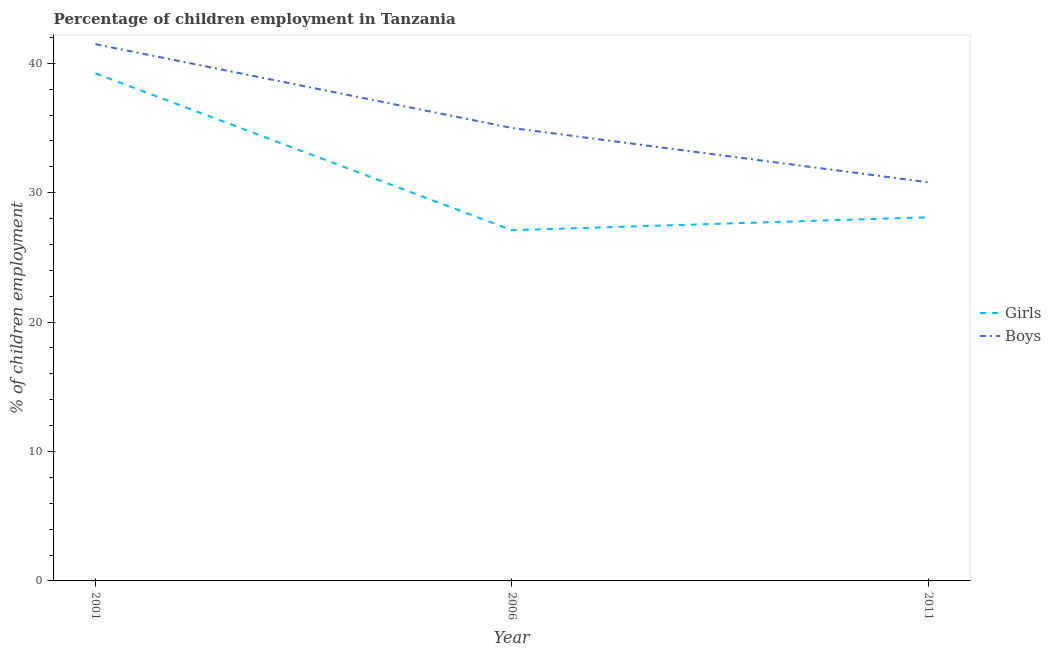Does the line corresponding to percentage of employed boys intersect with the line corresponding to percentage of employed girls?
Provide a succinct answer. No. Is the number of lines equal to the number of legend labels?
Your answer should be compact. Yes. What is the percentage of employed girls in 2011?
Offer a terse response. 28.1. Across all years, what is the maximum percentage of employed girls?
Provide a succinct answer. 39.22. Across all years, what is the minimum percentage of employed boys?
Your answer should be compact. 30.8. In which year was the percentage of employed boys maximum?
Give a very brief answer. 2001. What is the total percentage of employed boys in the graph?
Your answer should be very brief. 107.27. What is the difference between the percentage of employed girls in 2001 and that in 2011?
Offer a terse response. 11.12. What is the difference between the percentage of employed boys in 2006 and the percentage of employed girls in 2001?
Your answer should be compact. -4.22. What is the average percentage of employed girls per year?
Your answer should be compact. 31.47. In the year 2011, what is the difference between the percentage of employed girls and percentage of employed boys?
Keep it short and to the point. -2.7. In how many years, is the percentage of employed boys greater than 28 %?
Provide a short and direct response. 3. What is the ratio of the percentage of employed girls in 2006 to that in 2011?
Your response must be concise. 0.96. Is the percentage of employed boys in 2001 less than that in 2006?
Give a very brief answer. No. Is the difference between the percentage of employed girls in 2001 and 2011 greater than the difference between the percentage of employed boys in 2001 and 2011?
Give a very brief answer. Yes. What is the difference between the highest and the second highest percentage of employed boys?
Give a very brief answer. 6.47. What is the difference between the highest and the lowest percentage of employed girls?
Offer a terse response. 12.12. In how many years, is the percentage of employed boys greater than the average percentage of employed boys taken over all years?
Offer a terse response. 1. Is the sum of the percentage of employed boys in 2006 and 2011 greater than the maximum percentage of employed girls across all years?
Your answer should be very brief. Yes. Does the percentage of employed girls monotonically increase over the years?
Your response must be concise. No. Is the percentage of employed girls strictly greater than the percentage of employed boys over the years?
Your response must be concise. No. Is the percentage of employed girls strictly less than the percentage of employed boys over the years?
Ensure brevity in your answer.  Yes. How many years are there in the graph?
Offer a terse response. 3. What is the difference between two consecutive major ticks on the Y-axis?
Give a very brief answer. 10. How are the legend labels stacked?
Offer a very short reply. Vertical. What is the title of the graph?
Offer a terse response. Percentage of children employment in Tanzania. Does "Males" appear as one of the legend labels in the graph?
Your answer should be very brief. No. What is the label or title of the X-axis?
Your response must be concise. Year. What is the label or title of the Y-axis?
Your answer should be compact. % of children employment. What is the % of children employment of Girls in 2001?
Your answer should be very brief. 39.22. What is the % of children employment of Boys in 2001?
Give a very brief answer. 41.47. What is the % of children employment in Girls in 2006?
Offer a very short reply. 27.1. What is the % of children employment of Girls in 2011?
Give a very brief answer. 28.1. What is the % of children employment of Boys in 2011?
Keep it short and to the point. 30.8. Across all years, what is the maximum % of children employment in Girls?
Keep it short and to the point. 39.22. Across all years, what is the maximum % of children employment in Boys?
Give a very brief answer. 41.47. Across all years, what is the minimum % of children employment of Girls?
Provide a short and direct response. 27.1. Across all years, what is the minimum % of children employment in Boys?
Your response must be concise. 30.8. What is the total % of children employment in Girls in the graph?
Make the answer very short. 94.42. What is the total % of children employment of Boys in the graph?
Offer a very short reply. 107.27. What is the difference between the % of children employment in Girls in 2001 and that in 2006?
Provide a succinct answer. 12.12. What is the difference between the % of children employment of Boys in 2001 and that in 2006?
Provide a succinct answer. 6.47. What is the difference between the % of children employment of Girls in 2001 and that in 2011?
Give a very brief answer. 11.12. What is the difference between the % of children employment of Boys in 2001 and that in 2011?
Keep it short and to the point. 10.67. What is the difference between the % of children employment of Girls in 2006 and that in 2011?
Make the answer very short. -1. What is the difference between the % of children employment of Girls in 2001 and the % of children employment of Boys in 2006?
Make the answer very short. 4.22. What is the difference between the % of children employment in Girls in 2001 and the % of children employment in Boys in 2011?
Ensure brevity in your answer.  8.42. What is the difference between the % of children employment in Girls in 2006 and the % of children employment in Boys in 2011?
Provide a succinct answer. -3.7. What is the average % of children employment in Girls per year?
Provide a succinct answer. 31.47. What is the average % of children employment in Boys per year?
Provide a short and direct response. 35.76. In the year 2001, what is the difference between the % of children employment of Girls and % of children employment of Boys?
Your response must be concise. -2.25. What is the ratio of the % of children employment of Girls in 2001 to that in 2006?
Your answer should be very brief. 1.45. What is the ratio of the % of children employment in Boys in 2001 to that in 2006?
Your answer should be compact. 1.19. What is the ratio of the % of children employment in Girls in 2001 to that in 2011?
Your response must be concise. 1.4. What is the ratio of the % of children employment of Boys in 2001 to that in 2011?
Give a very brief answer. 1.35. What is the ratio of the % of children employment in Girls in 2006 to that in 2011?
Make the answer very short. 0.96. What is the ratio of the % of children employment of Boys in 2006 to that in 2011?
Your answer should be very brief. 1.14. What is the difference between the highest and the second highest % of children employment of Girls?
Give a very brief answer. 11.12. What is the difference between the highest and the second highest % of children employment in Boys?
Give a very brief answer. 6.47. What is the difference between the highest and the lowest % of children employment of Girls?
Provide a succinct answer. 12.12. What is the difference between the highest and the lowest % of children employment of Boys?
Give a very brief answer. 10.67. 